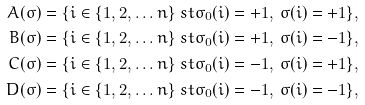Convert formula to latex. <formula><loc_0><loc_0><loc_500><loc_500>A ( \sigma ) & = \{ i \in \{ 1 , 2 , \dots n \} \ s t \sigma _ { 0 } ( i ) = + 1 , \, \sigma ( i ) = + 1 \} , \\ B ( \sigma ) & = \{ i \in \{ 1 , 2 , \dots n \} \ s t \sigma _ { 0 } ( i ) = + 1 , \, \sigma ( i ) = - 1 \} , \\ C ( \sigma ) & = \{ i \in \{ 1 , 2 , \dots n \} \ s t \sigma _ { 0 } ( i ) = - 1 , \, \sigma ( i ) = + 1 \} , \\ D ( \sigma ) & = \{ i \in \{ 1 , 2 , \dots n \} \ s t \sigma _ { 0 } ( i ) = - 1 , \, \sigma ( i ) = - 1 \} ,</formula> 